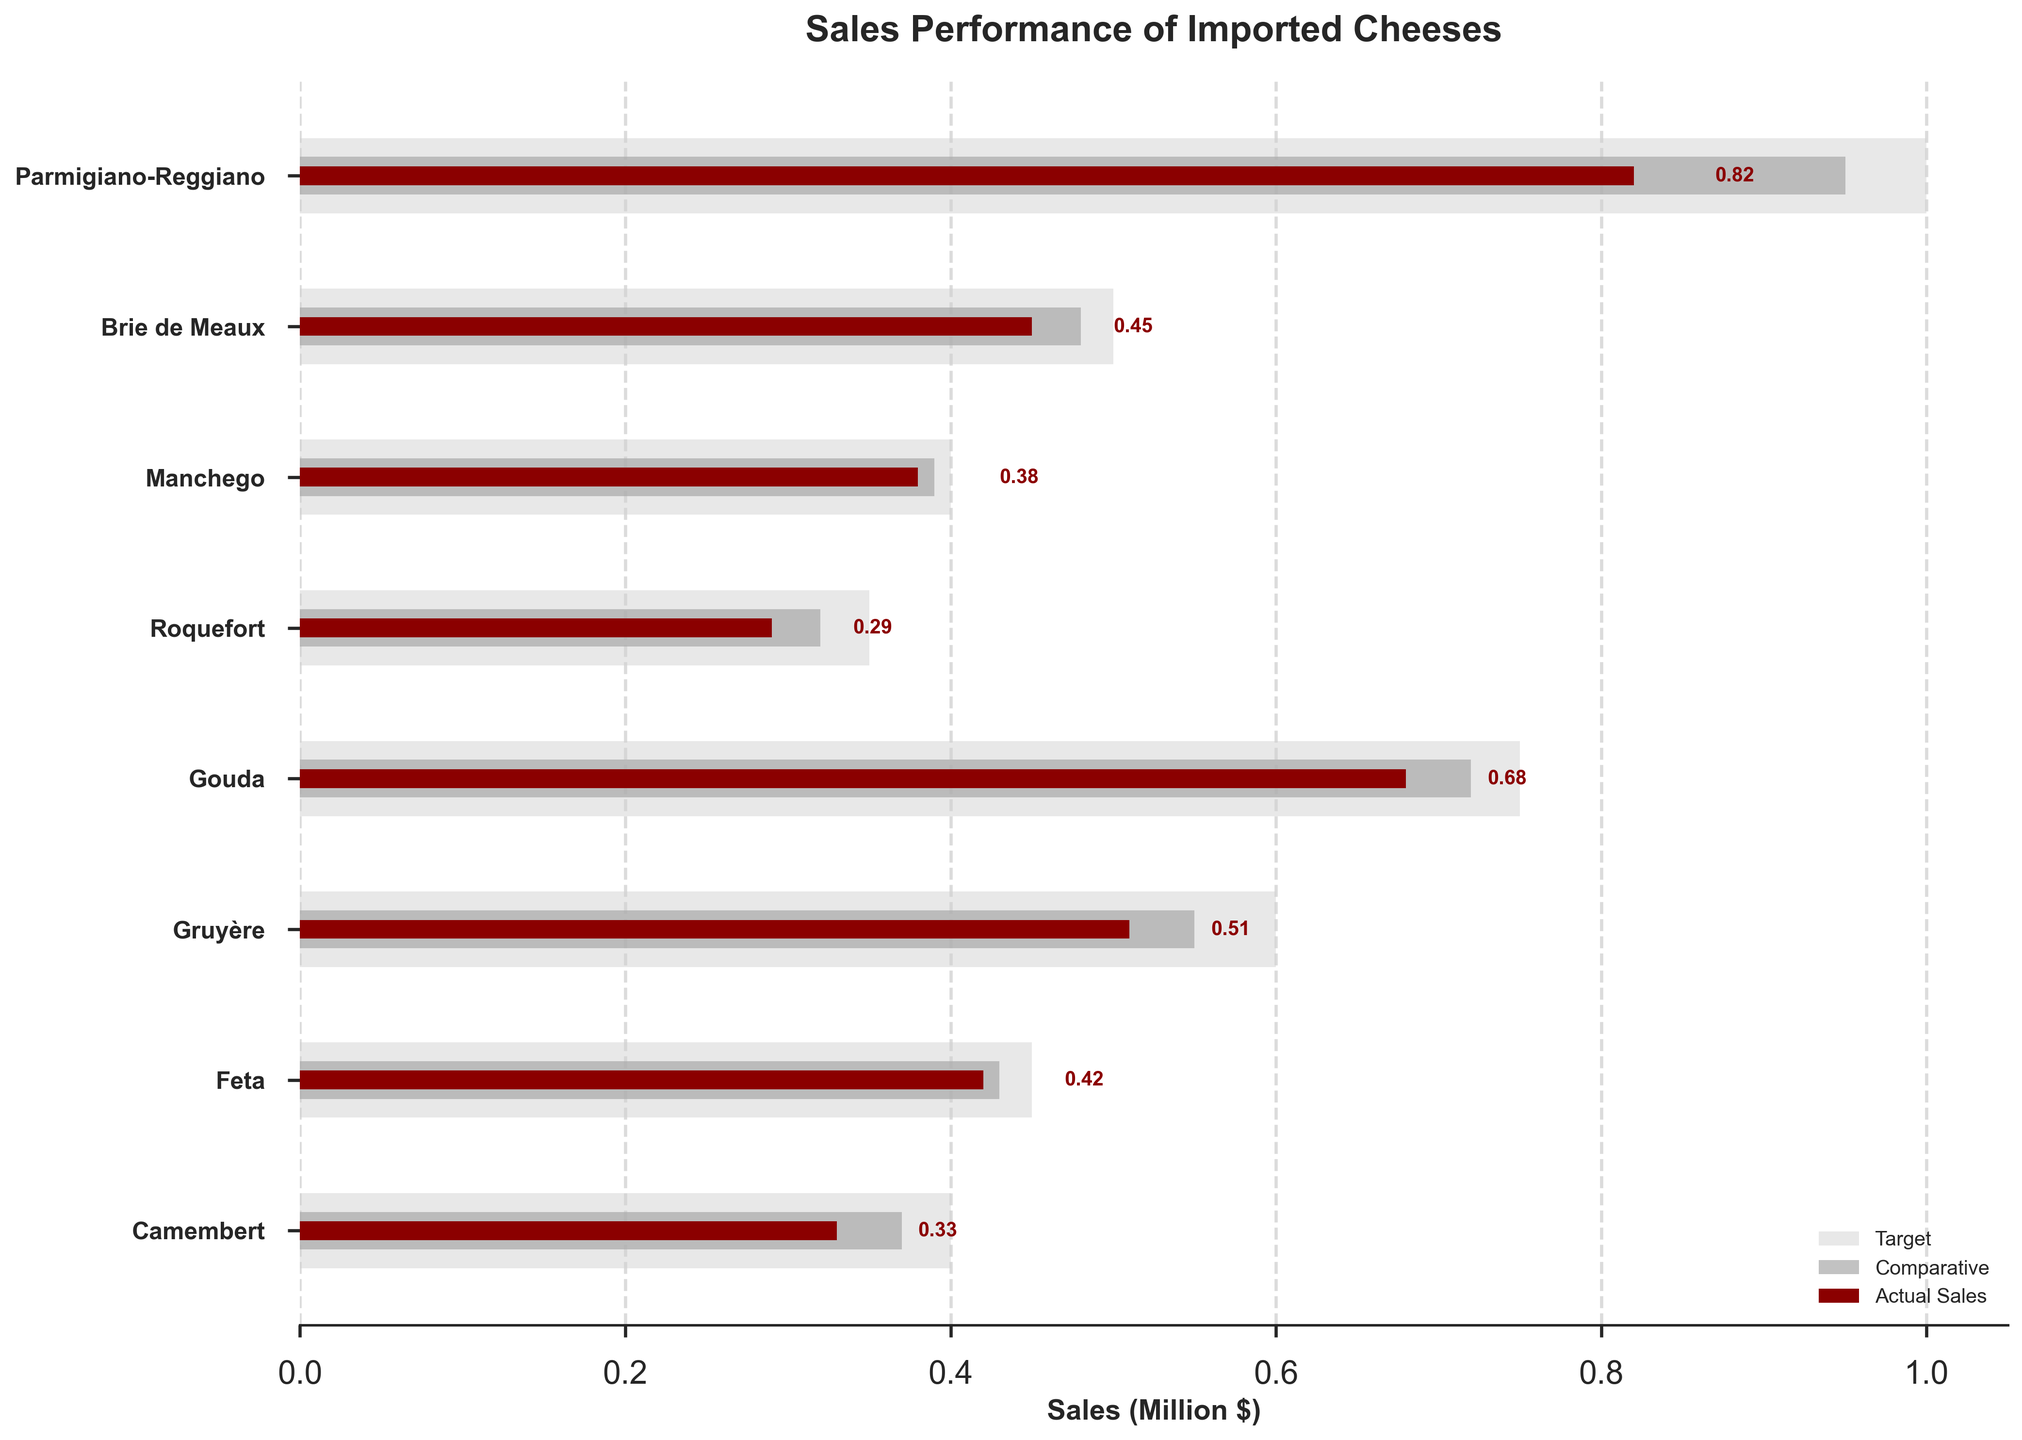What's the title of the chart? The chart's title is located at the center-top of the figure. It describes the main topic or data presented in the chart.
Answer: Sales Performance of Imported Cheeses Which cheese category has the highest actual sales? By examining the horizontal bars representing actual sales, the cheese category with the longest bar indicates the highest actual sales.
Answer: Parmigiano-Reggiano How do actual sales of Roquefort compare to its target and comparative measure? Look at the three bars for Roquefort: the light grey bar for target, the dark grey bar for comparative, and the dark red bar for actual sales. Measure the lengths of each and compare them.
Answer: Actual sales are lower than both target and comparative measure What is the difference between the target and actual sales for Brie de Meaux? Subtract the actual sales value of Brie de Meaux from its target value. This involves referencing the respective bars' lengths in the figure.
Answer: 50,000 Which cheese has a closer actual sales value to its target, Manchego or Feta? Compare the distances between actual and target bars for Manchego and Feta. The cheese with the smaller gap has an actual sales value closer to its target.
Answer: Manchego Which two cheese categories have the smallest difference between their comparative measure and target? Calculate the difference between the comparative measure and target for each cheese, then identify the two smallest differences.
Answer: Manchego, Feta What is the total target sales of all cheese categories combined? Sum the target sales values for each cheese category.
Answer: 4,000,000 How many cheese categories have actual sales that exceed their comparative measure? Count the number of cheese categories where the dark red bar (actual sales) is longer than the dark grey bar (comparative measure).
Answer: 3 (Manchego, Feta, Gouda) What's the average actual sales value for all eight cheese categories? Sum all the actual sales values and then divide by the number of cheese categories (8).
Answer: 485,000 